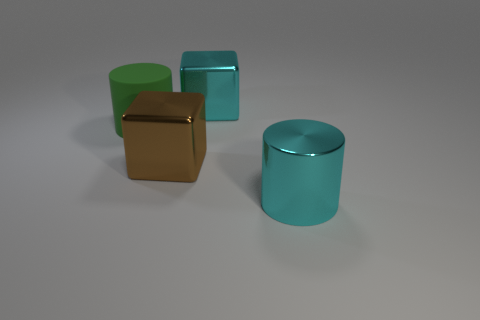The metallic cube that is the same color as the metal cylinder is what size?
Give a very brief answer. Large. How many other things are there of the same size as the matte object?
Offer a very short reply. 3. Is the color of the large rubber thing the same as the block on the right side of the big brown shiny block?
Provide a succinct answer. No. Is the number of large green things in front of the cyan shiny cylinder less than the number of large green matte cylinders behind the big cyan metallic cube?
Ensure brevity in your answer.  No. There is a large object that is both to the left of the cyan metallic block and to the right of the big green matte object; what color is it?
Offer a terse response. Brown. There is a brown metal block; is it the same size as the cyan metallic object on the left side of the large shiny cylinder?
Your answer should be compact. Yes. What shape is the big thing behind the green rubber cylinder?
Offer a very short reply. Cube. Is there any other thing that is made of the same material as the large brown object?
Your answer should be compact. Yes. Is the number of large brown objects that are to the right of the large cyan cube greater than the number of big cyan metal things?
Your answer should be very brief. No. What number of big cyan metallic things are behind the big metal thing that is in front of the shiny block that is left of the large cyan metal block?
Give a very brief answer. 1. 